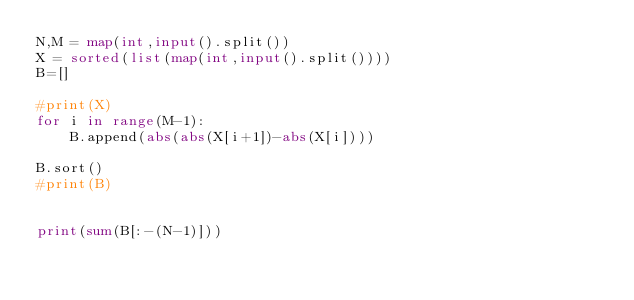<code> <loc_0><loc_0><loc_500><loc_500><_Python_>N,M = map(int,input().split())
X = sorted(list(map(int,input().split())))
B=[]

#print(X)
for i in range(M-1):
    B.append(abs(abs(X[i+1])-abs(X[i])))

B.sort()
#print(B)


print(sum(B[:-(N-1)]))

</code> 